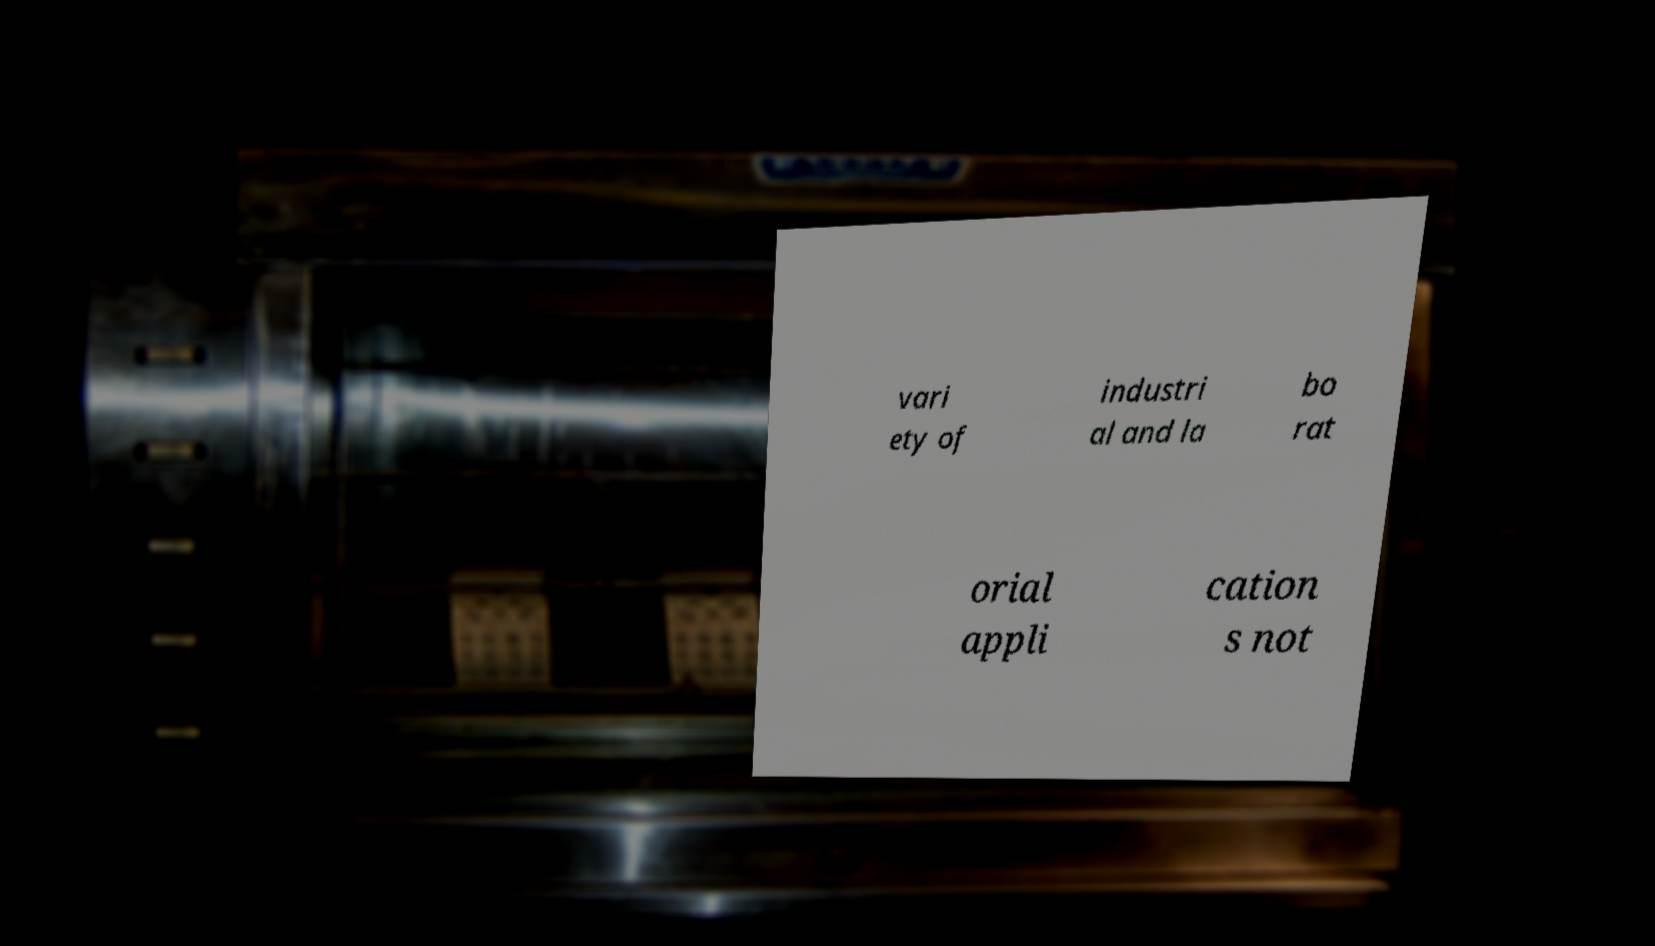There's text embedded in this image that I need extracted. Can you transcribe it verbatim? vari ety of industri al and la bo rat orial appli cation s not 